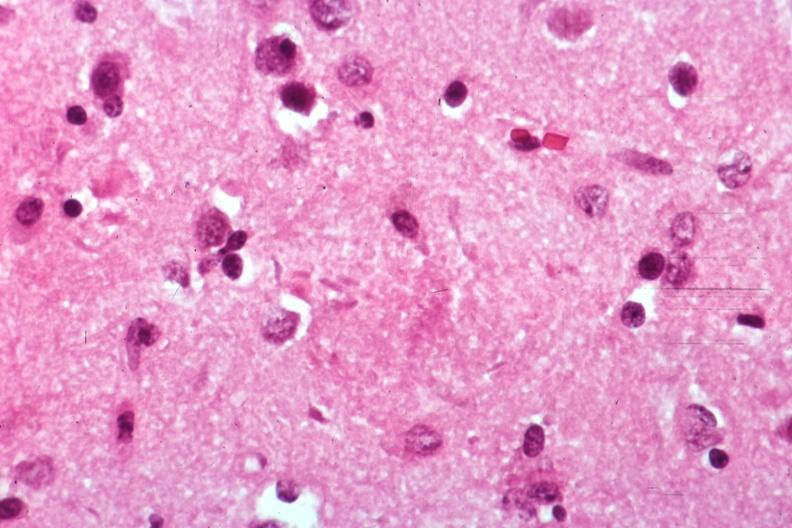s alzheimers present?
Answer the question using a single word or phrase. Yes 